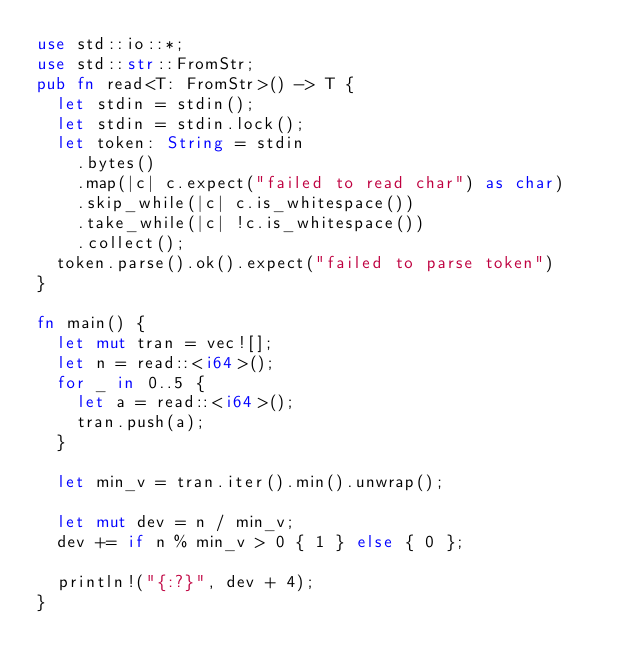<code> <loc_0><loc_0><loc_500><loc_500><_Rust_>use std::io::*;
use std::str::FromStr;
pub fn read<T: FromStr>() -> T {
  let stdin = stdin();
  let stdin = stdin.lock();
  let token: String = stdin
    .bytes()
    .map(|c| c.expect("failed to read char") as char)
    .skip_while(|c| c.is_whitespace())
    .take_while(|c| !c.is_whitespace())
    .collect();
  token.parse().ok().expect("failed to parse token")
}

fn main() {
  let mut tran = vec![];
  let n = read::<i64>();
  for _ in 0..5 {
    let a = read::<i64>();
    tran.push(a);
  }

  let min_v = tran.iter().min().unwrap();

  let mut dev = n / min_v;
  dev += if n % min_v > 0 { 1 } else { 0 };

  println!("{:?}", dev + 4);
}

</code> 